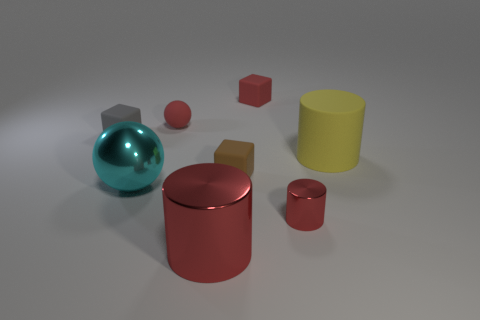There is a tiny cylinder that is the same color as the big metallic cylinder; what is it made of?
Make the answer very short. Metal. Are there any red cubes left of the cyan object?
Your answer should be compact. No. How many rubber things are either large red things or small green objects?
Your answer should be very brief. 0. How many tiny red rubber objects are right of the big red metallic cylinder?
Your response must be concise. 1. Are there any things that have the same size as the cyan metal ball?
Offer a very short reply. Yes. Is there a thing of the same color as the metal sphere?
Keep it short and to the point. No. Is there anything else that is the same size as the brown rubber cube?
Ensure brevity in your answer.  Yes. How many balls have the same color as the small shiny thing?
Keep it short and to the point. 1. There is a small matte sphere; is it the same color as the big cylinder that is in front of the big ball?
Your answer should be compact. Yes. What number of things are gray rubber cubes or large cylinders that are to the left of the large yellow cylinder?
Your answer should be compact. 2. 